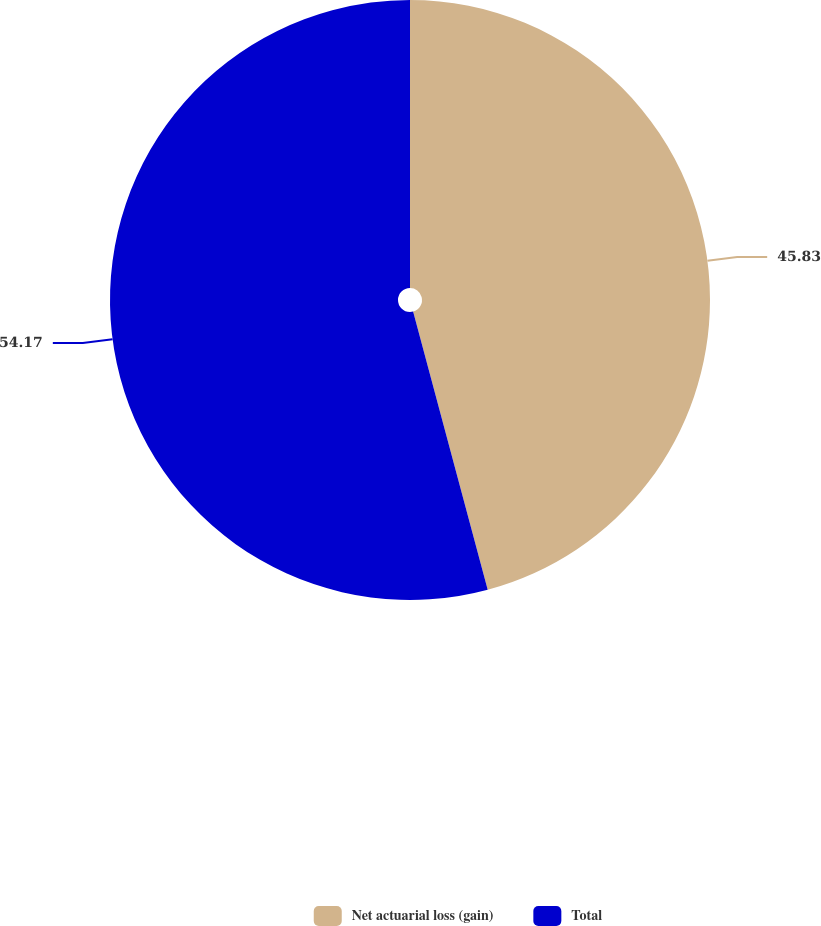<chart> <loc_0><loc_0><loc_500><loc_500><pie_chart><fcel>Net actuarial loss (gain)<fcel>Total<nl><fcel>45.83%<fcel>54.17%<nl></chart> 